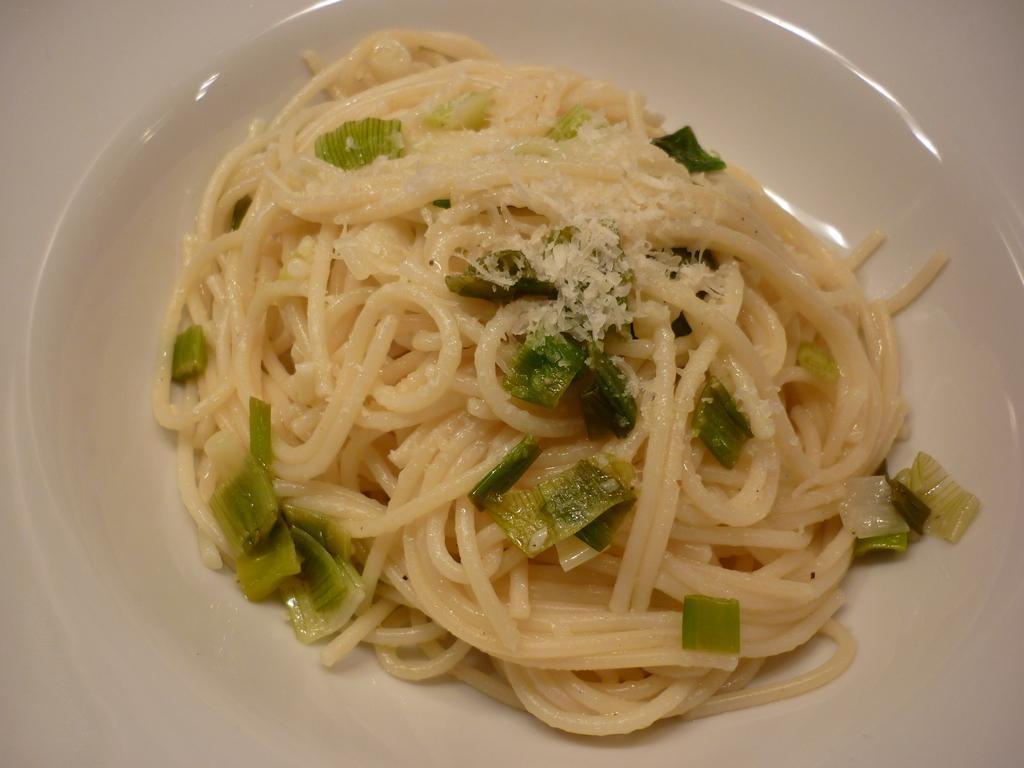Could you give a brief overview of what you see in this image? In this picture we can see a food item in a plate. At the edges there is some white color object. 